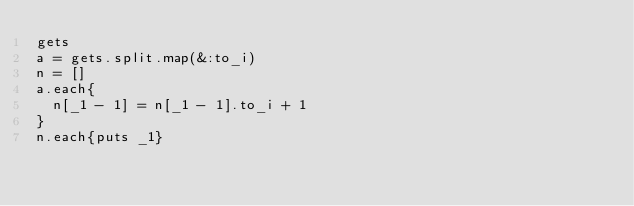Convert code to text. <code><loc_0><loc_0><loc_500><loc_500><_Ruby_>gets
a = gets.split.map(&:to_i)
n = []
a.each{
  n[_1 - 1] = n[_1 - 1].to_i + 1
}
n.each{puts _1}</code> 